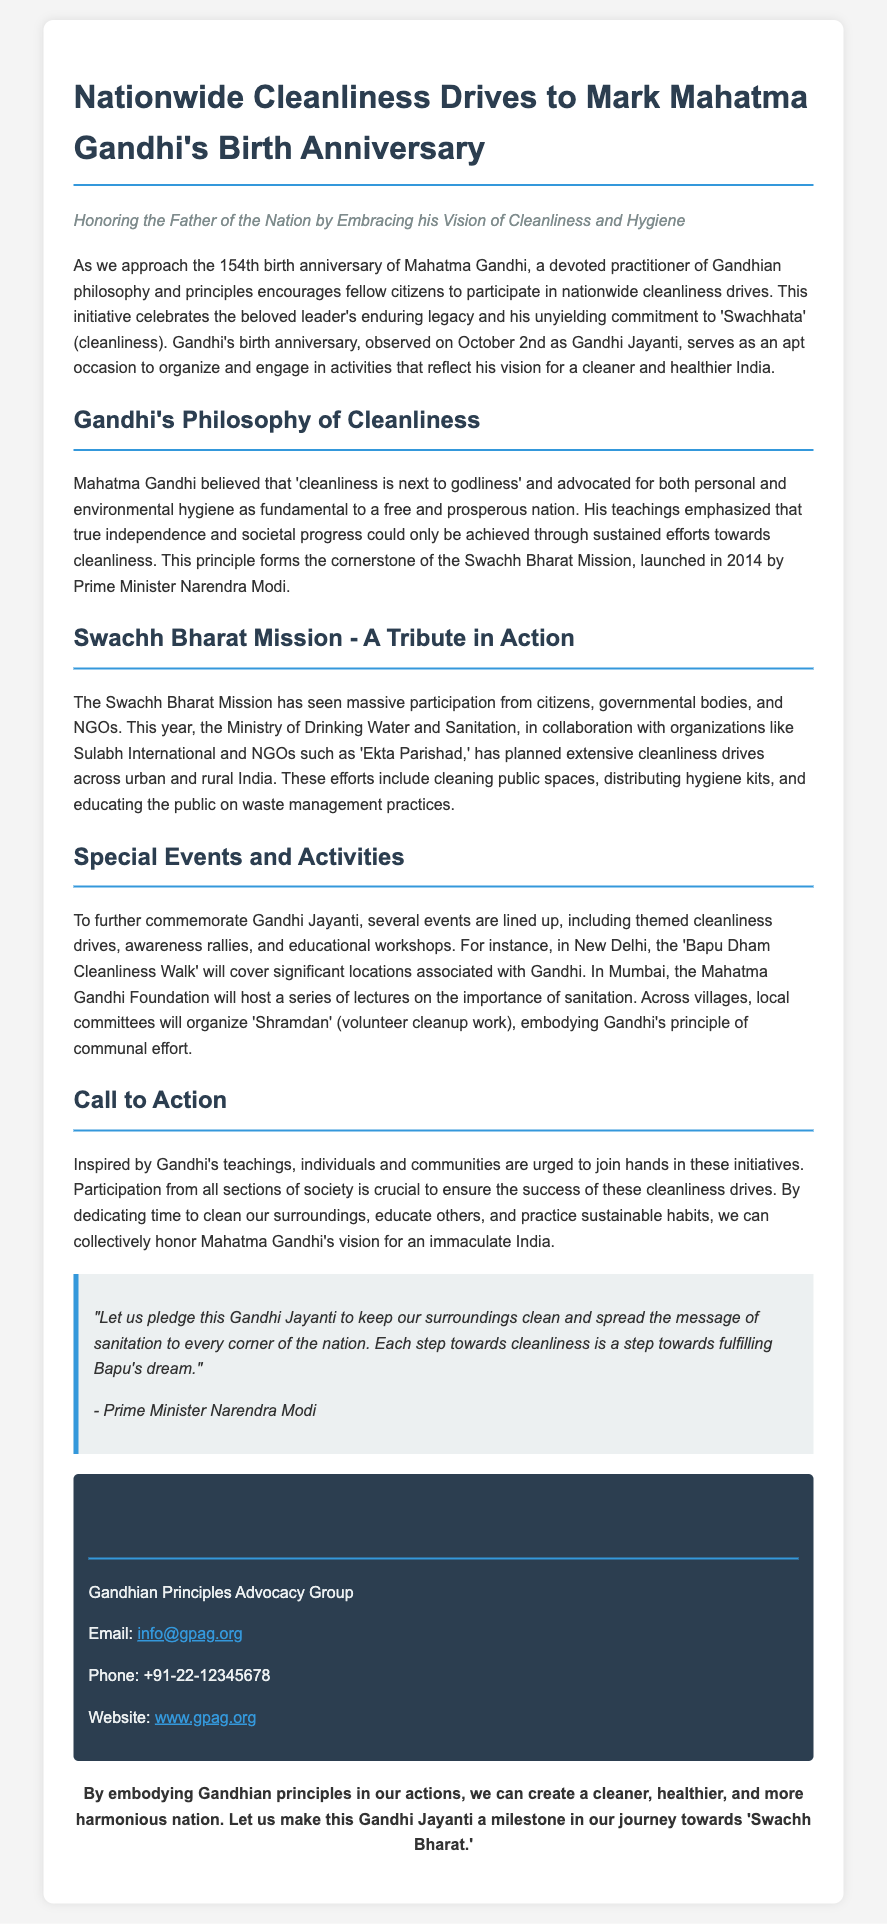What is being commemorated on October 2nd? The document states that Mahatma Gandhi's 154th birth anniversary is being commemorated on October 2nd.
Answer: Mahatma Gandhi's 154th birth anniversary What principle did Mahatma Gandhi emphasize as fundamental to a free nation? The document mentions that Gandhi believed cleanliness was essential for independence and societal progress.
Answer: Cleanliness What is the name of the initiative launched in 2014 by Prime Minister Narendra Modi? The document refers to the "Swachh Bharat Mission" as the initiative launched in 2014.
Answer: Swachh Bharat Mission What significant event is happening in New Delhi for Gandhi Jayanti? The document lists the "Bapu Dham Cleanliness Walk" as a significant event in New Delhi.
Answer: Bapu Dham Cleanliness Walk Who organized the nationwide cleanliness drives? The Ministry of Drinking Water and Sanitation, along with organizations like Sulabh International, is organizing the cleanliness drives.
Answer: Ministry of Drinking Water and Sanitation What is the quote attributed to Prime Minister Narendra Modi? The document provides a quote where Modi pledges to keep surroundings clean and spread the message of sanitation.
Answer: "Let us pledge this Gandhi Jayanti to keep our surroundings clean..." What does "Shramdan" mean in the context of the document? The document mentions "Shramdan" as volunteer cleanup work organized by local committees.
Answer: Volunteer cleanup work What is the underlying message of the press release? The document encourages collective action towards cleanliness in honor of Gandhi's vision for India.
Answer: Collective action towards cleanliness 